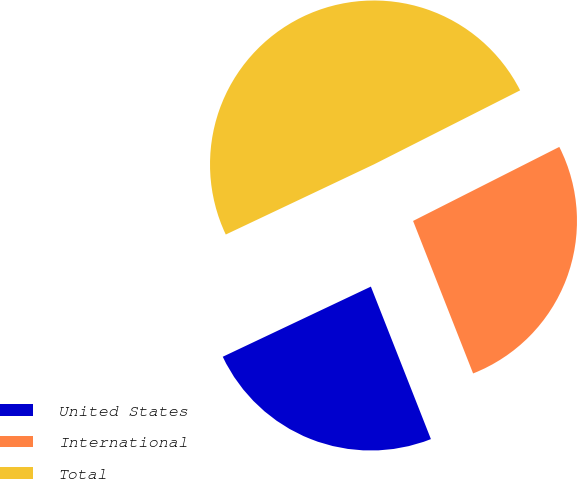Convert chart. <chart><loc_0><loc_0><loc_500><loc_500><pie_chart><fcel>United States<fcel>International<fcel>Total<nl><fcel>23.93%<fcel>26.49%<fcel>49.58%<nl></chart> 